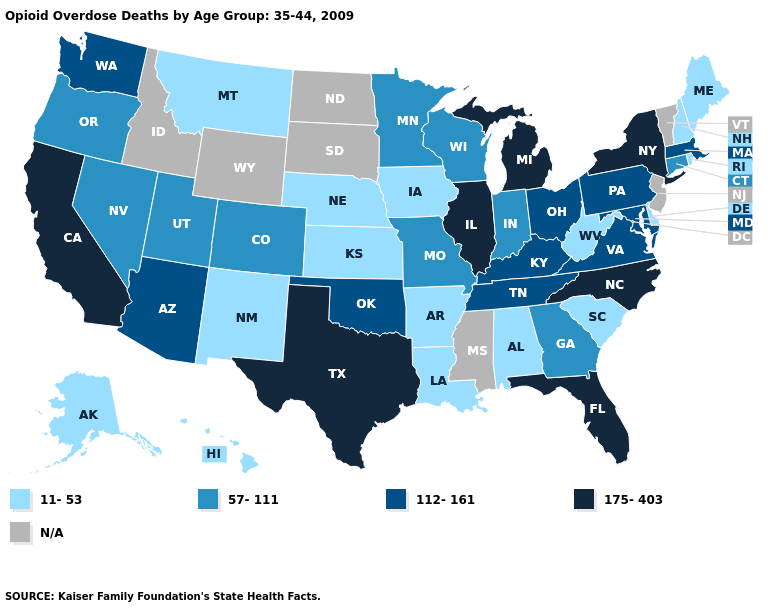What is the highest value in the USA?
Write a very short answer. 175-403. What is the highest value in the MidWest ?
Be succinct. 175-403. What is the highest value in the USA?
Keep it brief. 175-403. Name the states that have a value in the range 112-161?
Give a very brief answer. Arizona, Kentucky, Maryland, Massachusetts, Ohio, Oklahoma, Pennsylvania, Tennessee, Virginia, Washington. Name the states that have a value in the range 175-403?
Keep it brief. California, Florida, Illinois, Michigan, New York, North Carolina, Texas. Among the states that border Texas , which have the lowest value?
Answer briefly. Arkansas, Louisiana, New Mexico. What is the value of Kansas?
Give a very brief answer. 11-53. What is the value of Oregon?
Quick response, please. 57-111. What is the highest value in the USA?
Answer briefly. 175-403. What is the highest value in states that border Oregon?
Give a very brief answer. 175-403. Which states have the highest value in the USA?
Answer briefly. California, Florida, Illinois, Michigan, New York, North Carolina, Texas. Name the states that have a value in the range 175-403?
Short answer required. California, Florida, Illinois, Michigan, New York, North Carolina, Texas. What is the value of Maine?
Keep it brief. 11-53. 